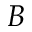Convert formula to latex. <formula><loc_0><loc_0><loc_500><loc_500>B</formula> 